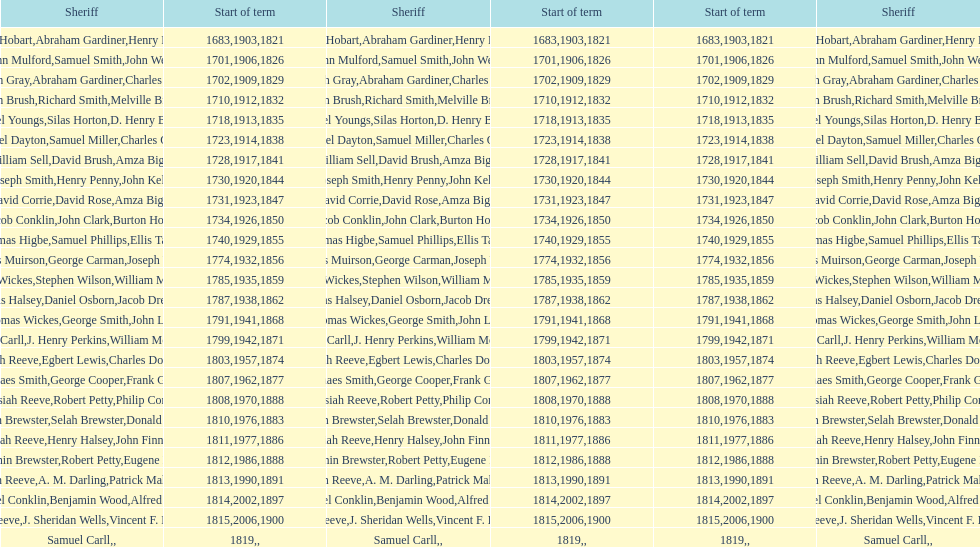When did benjamin brewster serve his second term? 1812. 